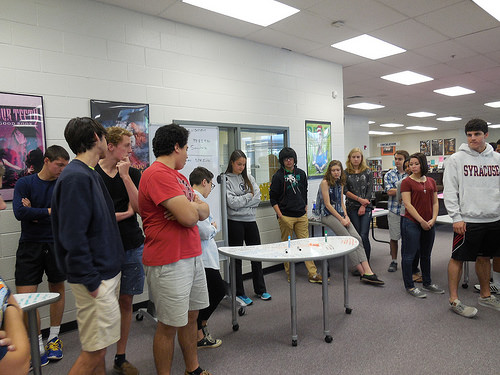<image>
Is the woman behind the table? No. The woman is not behind the table. From this viewpoint, the woman appears to be positioned elsewhere in the scene. Where is the table in relation to the girl? Is it behind the girl? No. The table is not behind the girl. From this viewpoint, the table appears to be positioned elsewhere in the scene. Is the girl to the right of the table? No. The girl is not to the right of the table. The horizontal positioning shows a different relationship. 